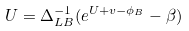<formula> <loc_0><loc_0><loc_500><loc_500>U = \Delta _ { L B } ^ { - 1 } ( e ^ { U + v - \phi _ { B } } - \beta )</formula> 